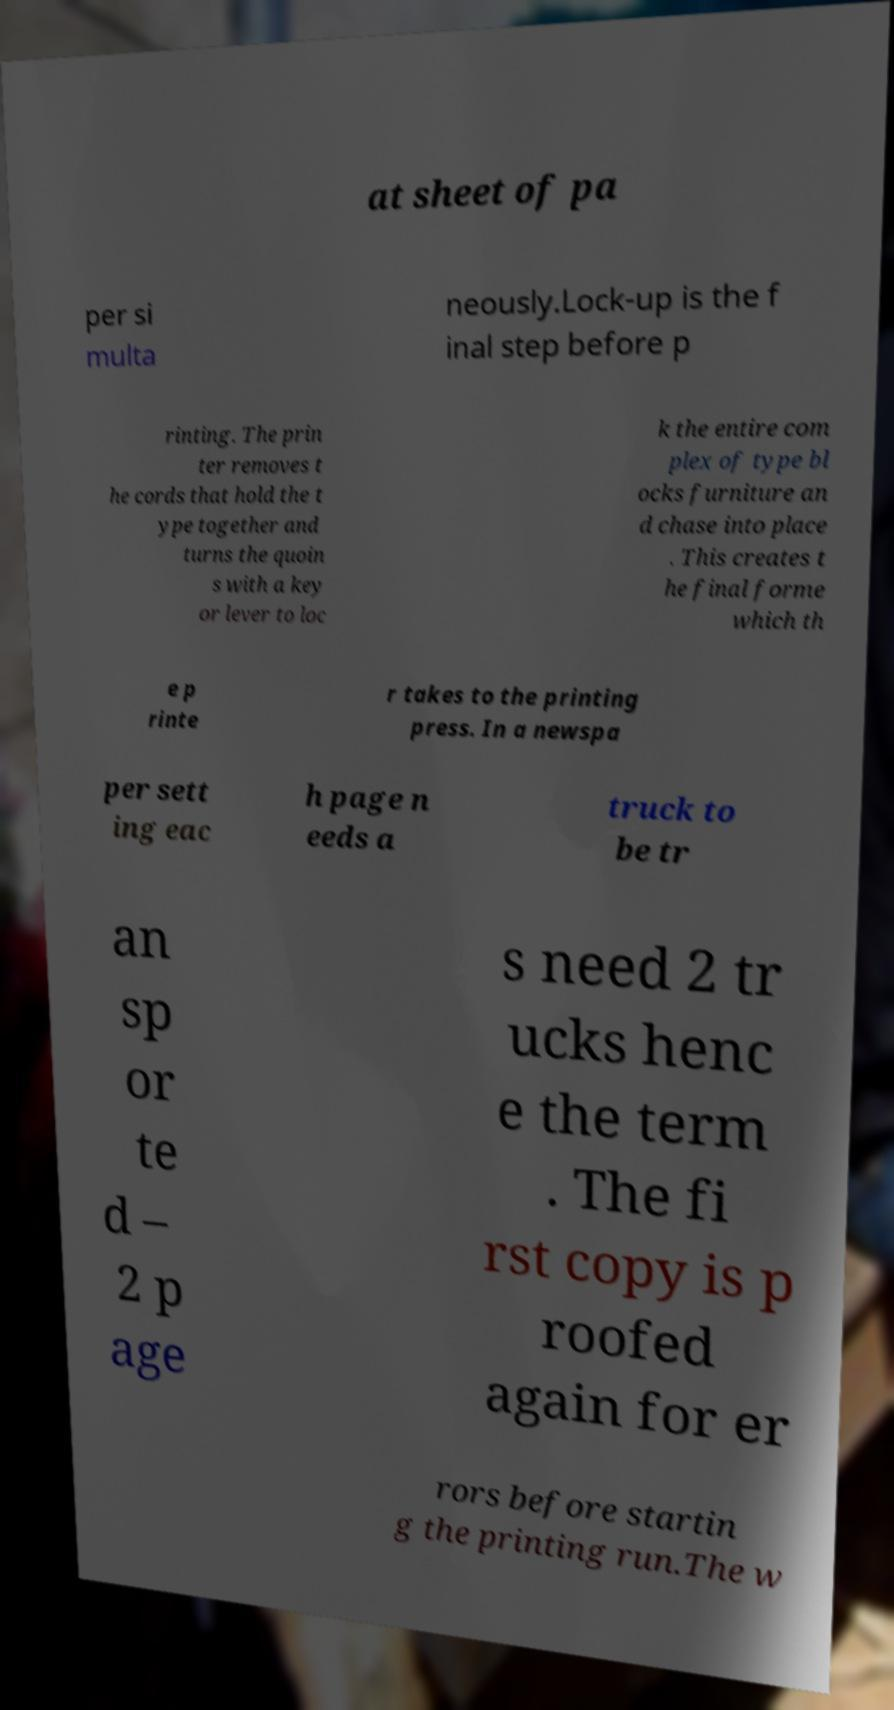For documentation purposes, I need the text within this image transcribed. Could you provide that? at sheet of pa per si multa neously.Lock-up is the f inal step before p rinting. The prin ter removes t he cords that hold the t ype together and turns the quoin s with a key or lever to loc k the entire com plex of type bl ocks furniture an d chase into place . This creates t he final forme which th e p rinte r takes to the printing press. In a newspa per sett ing eac h page n eeds a truck to be tr an sp or te d – 2 p age s need 2 tr ucks henc e the term . The fi rst copy is p roofed again for er rors before startin g the printing run.The w 